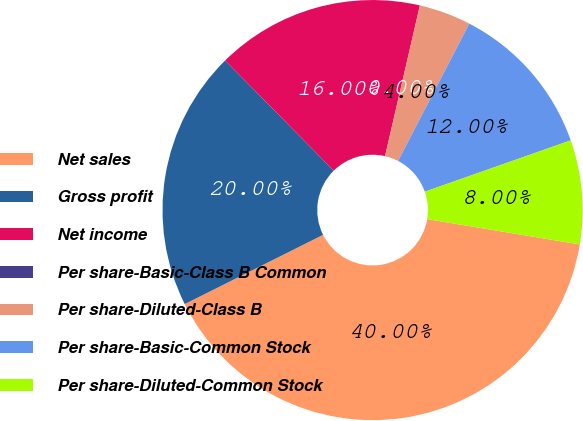Convert chart to OTSL. <chart><loc_0><loc_0><loc_500><loc_500><pie_chart><fcel>Net sales<fcel>Gross profit<fcel>Net income<fcel>Per share-Basic-Class B Common<fcel>Per share-Diluted-Class B<fcel>Per share-Basic-Common Stock<fcel>Per share-Diluted-Common Stock<nl><fcel>40.0%<fcel>20.0%<fcel>16.0%<fcel>0.0%<fcel>4.0%<fcel>12.0%<fcel>8.0%<nl></chart> 